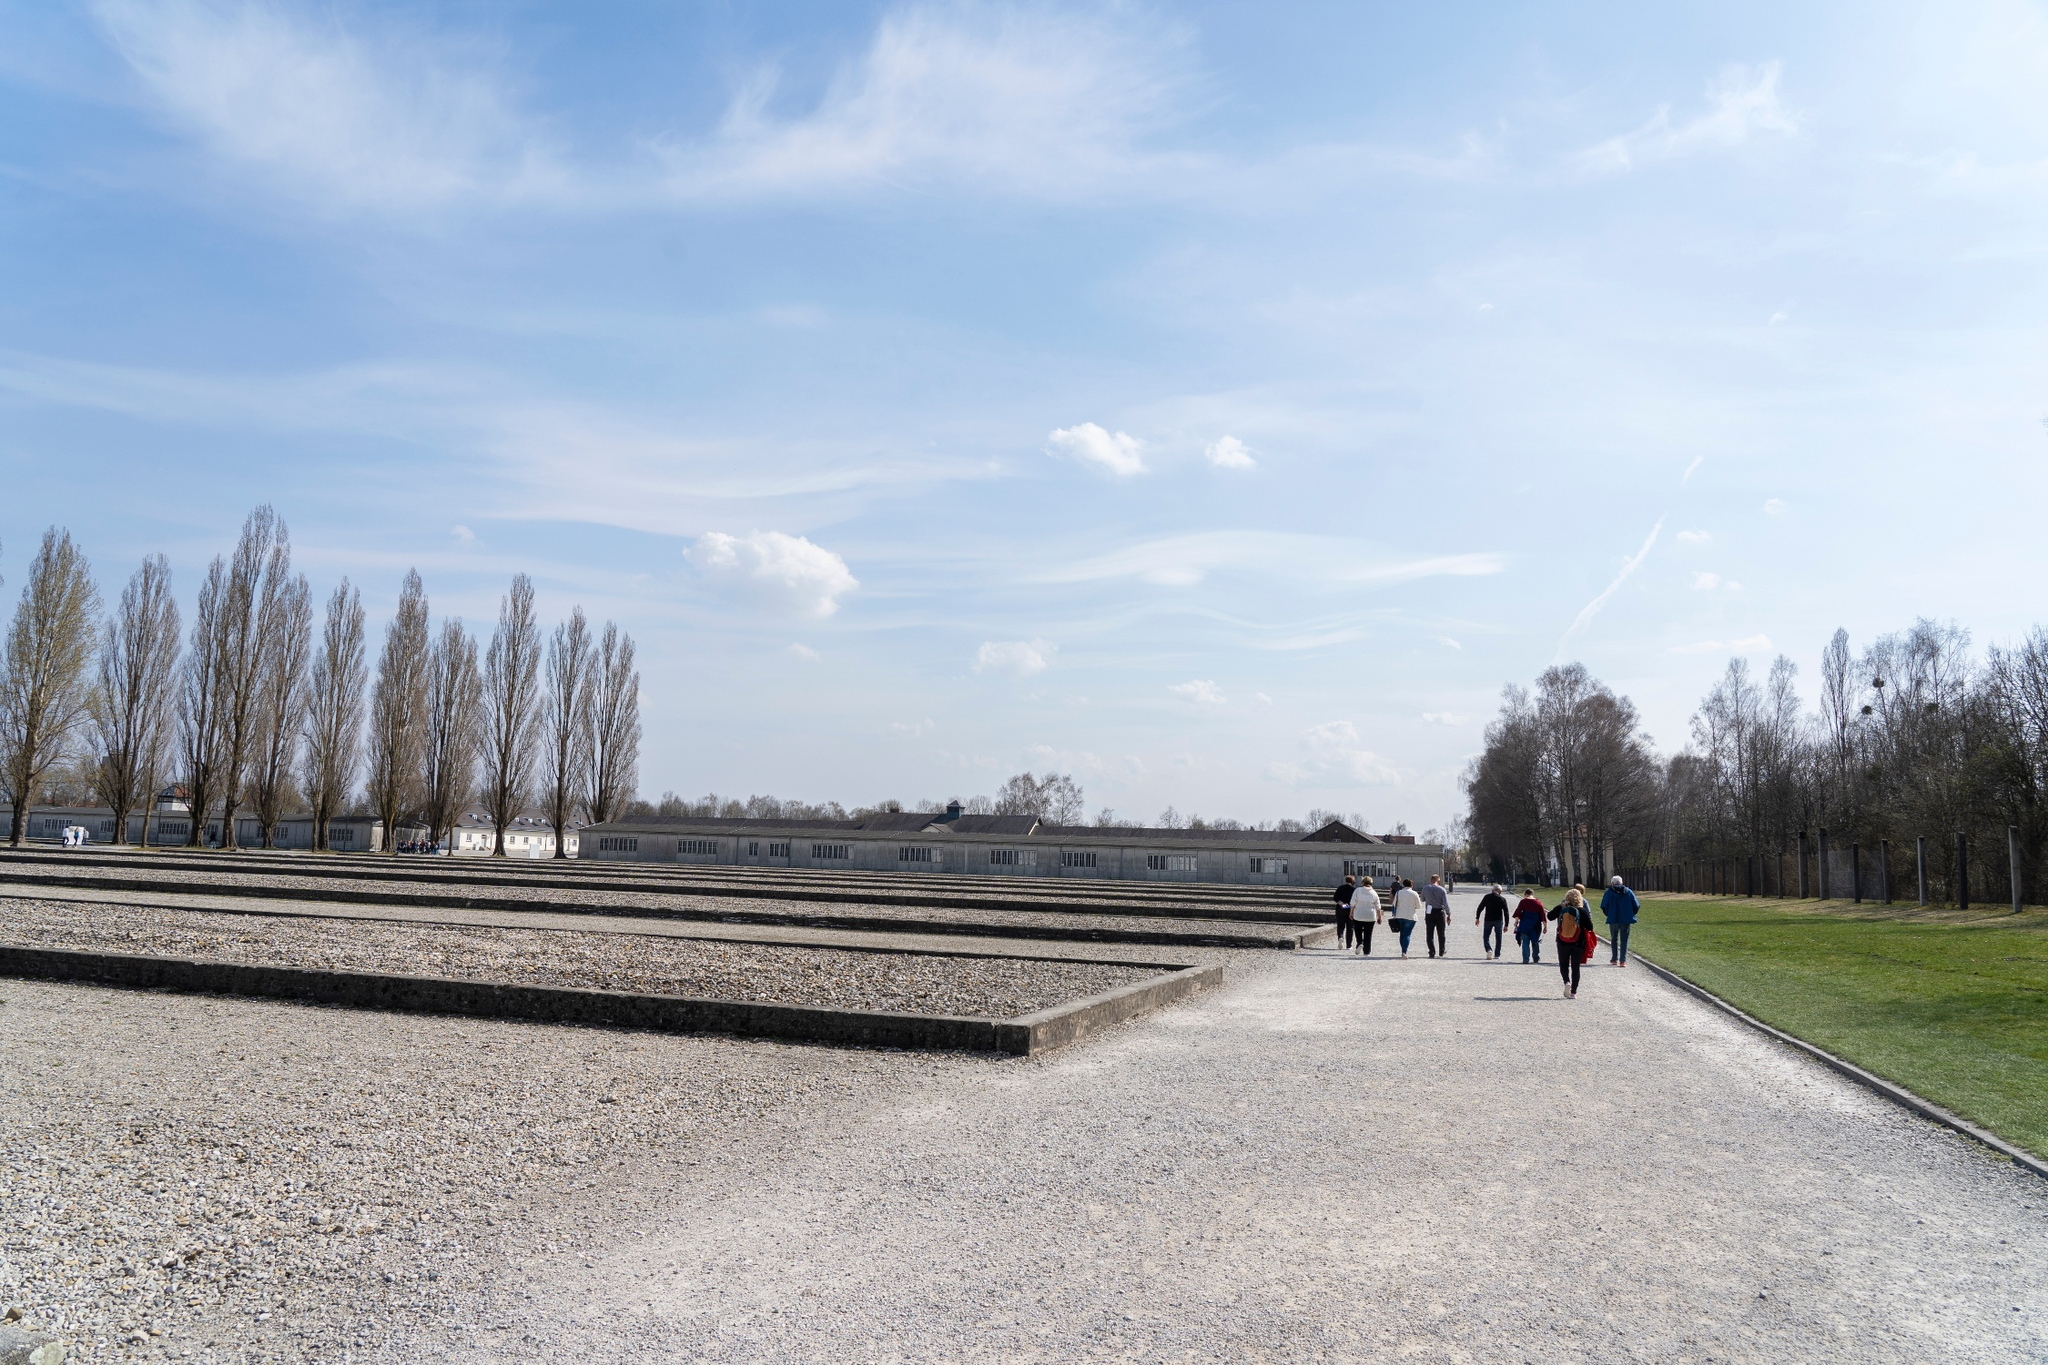What is a very creative question you might ask about the image? If the memorial site in the image could speak, what stories would it tell about the people who have visited it over the years, and how would it describe the changes in humanity's perspective on history since it was first established? 